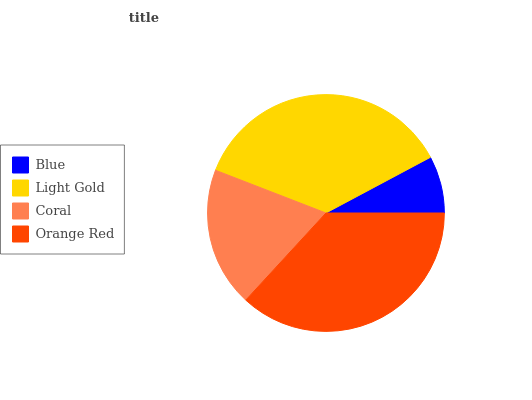Is Blue the minimum?
Answer yes or no. Yes. Is Orange Red the maximum?
Answer yes or no. Yes. Is Light Gold the minimum?
Answer yes or no. No. Is Light Gold the maximum?
Answer yes or no. No. Is Light Gold greater than Blue?
Answer yes or no. Yes. Is Blue less than Light Gold?
Answer yes or no. Yes. Is Blue greater than Light Gold?
Answer yes or no. No. Is Light Gold less than Blue?
Answer yes or no. No. Is Light Gold the high median?
Answer yes or no. Yes. Is Coral the low median?
Answer yes or no. Yes. Is Blue the high median?
Answer yes or no. No. Is Orange Red the low median?
Answer yes or no. No. 